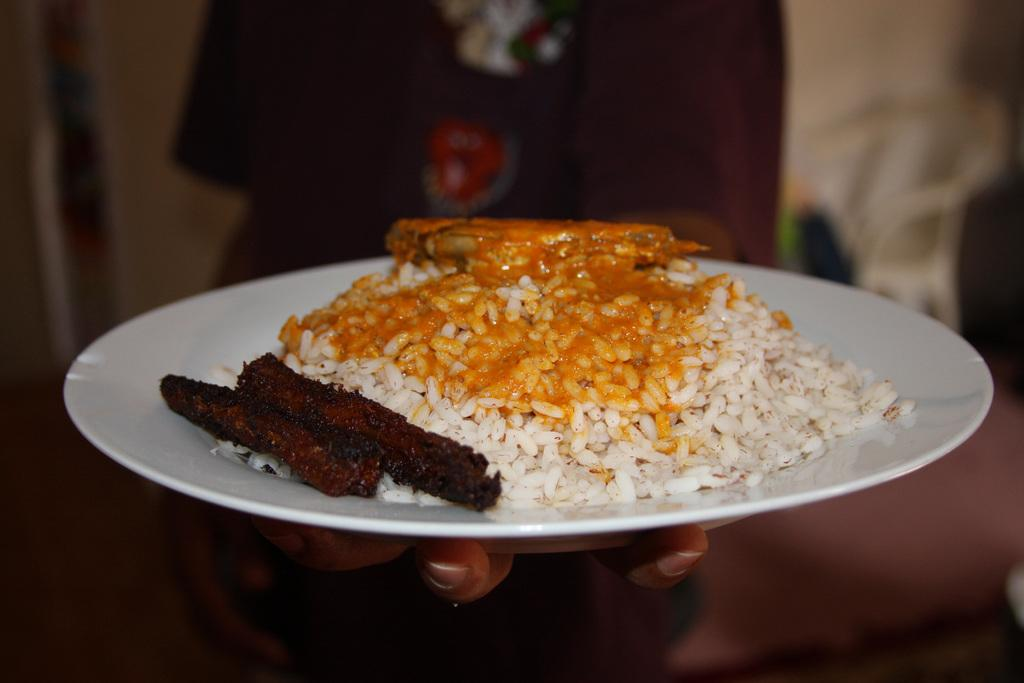What is the main subject of the image? There is a person in the image. What is the person holding in the image? The person is holding a plate. What can be found on the plate? There are food items on the plate. What is located behind the person? There is a chair behind the person. How would you describe the background of the image? The background of the image is blurred. What type of bottle can be seen in the image? There is no bottle present in the image. Can you hear thunder in the image? There is no sound in the image, so it is impossible to hear thunder. 